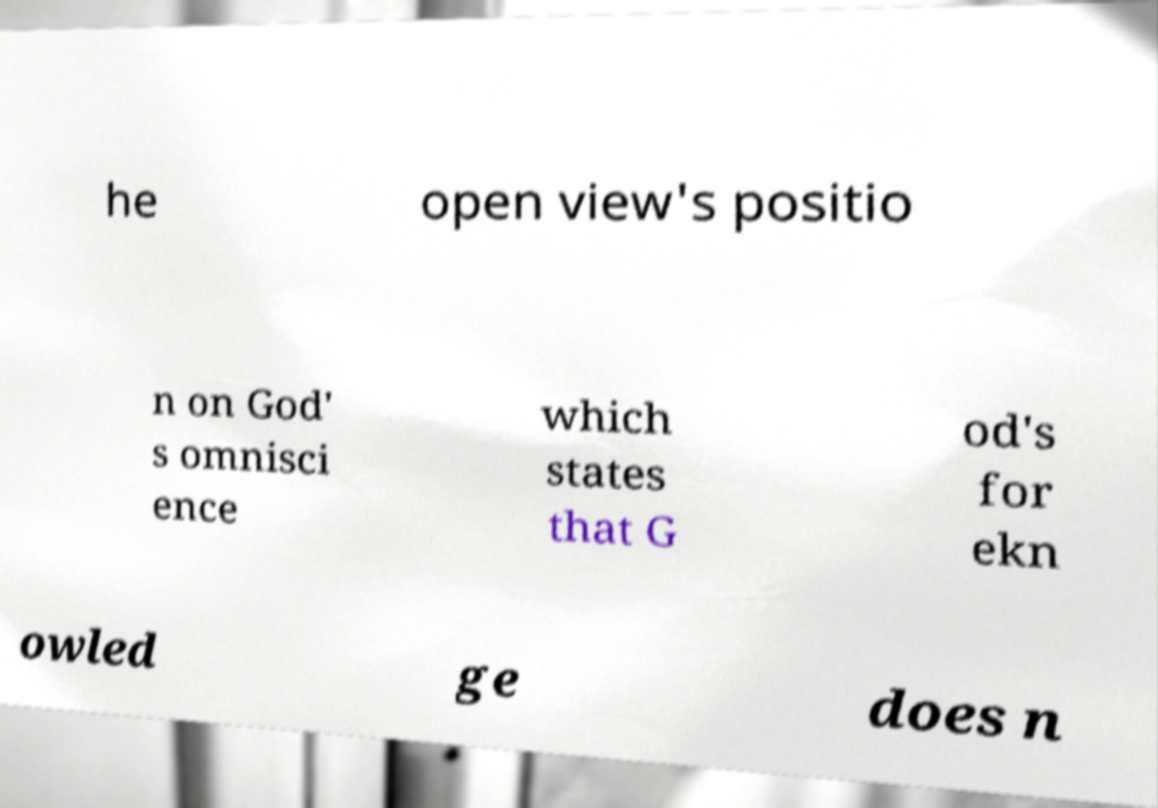There's text embedded in this image that I need extracted. Can you transcribe it verbatim? he open view's positio n on God' s omnisci ence which states that G od's for ekn owled ge does n 